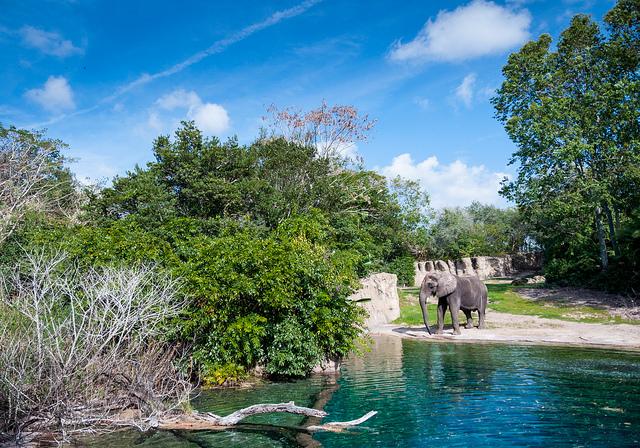What is in the water?
Write a very short answer. Tree. Is the elephant drinking?
Be succinct. No. What city is this picture taken in?
Answer briefly. No. Are the elephants in the water?
Keep it brief. No. Is the elephant in it's natural environment?
Concise answer only. Yes. Is the elephant alone?
Be succinct. Yes. Are there rocks by the water?
Keep it brief. Yes. Will this elephant cross the river?
Concise answer only. No. Is the elephant real or fake?
Concise answer only. Real. 